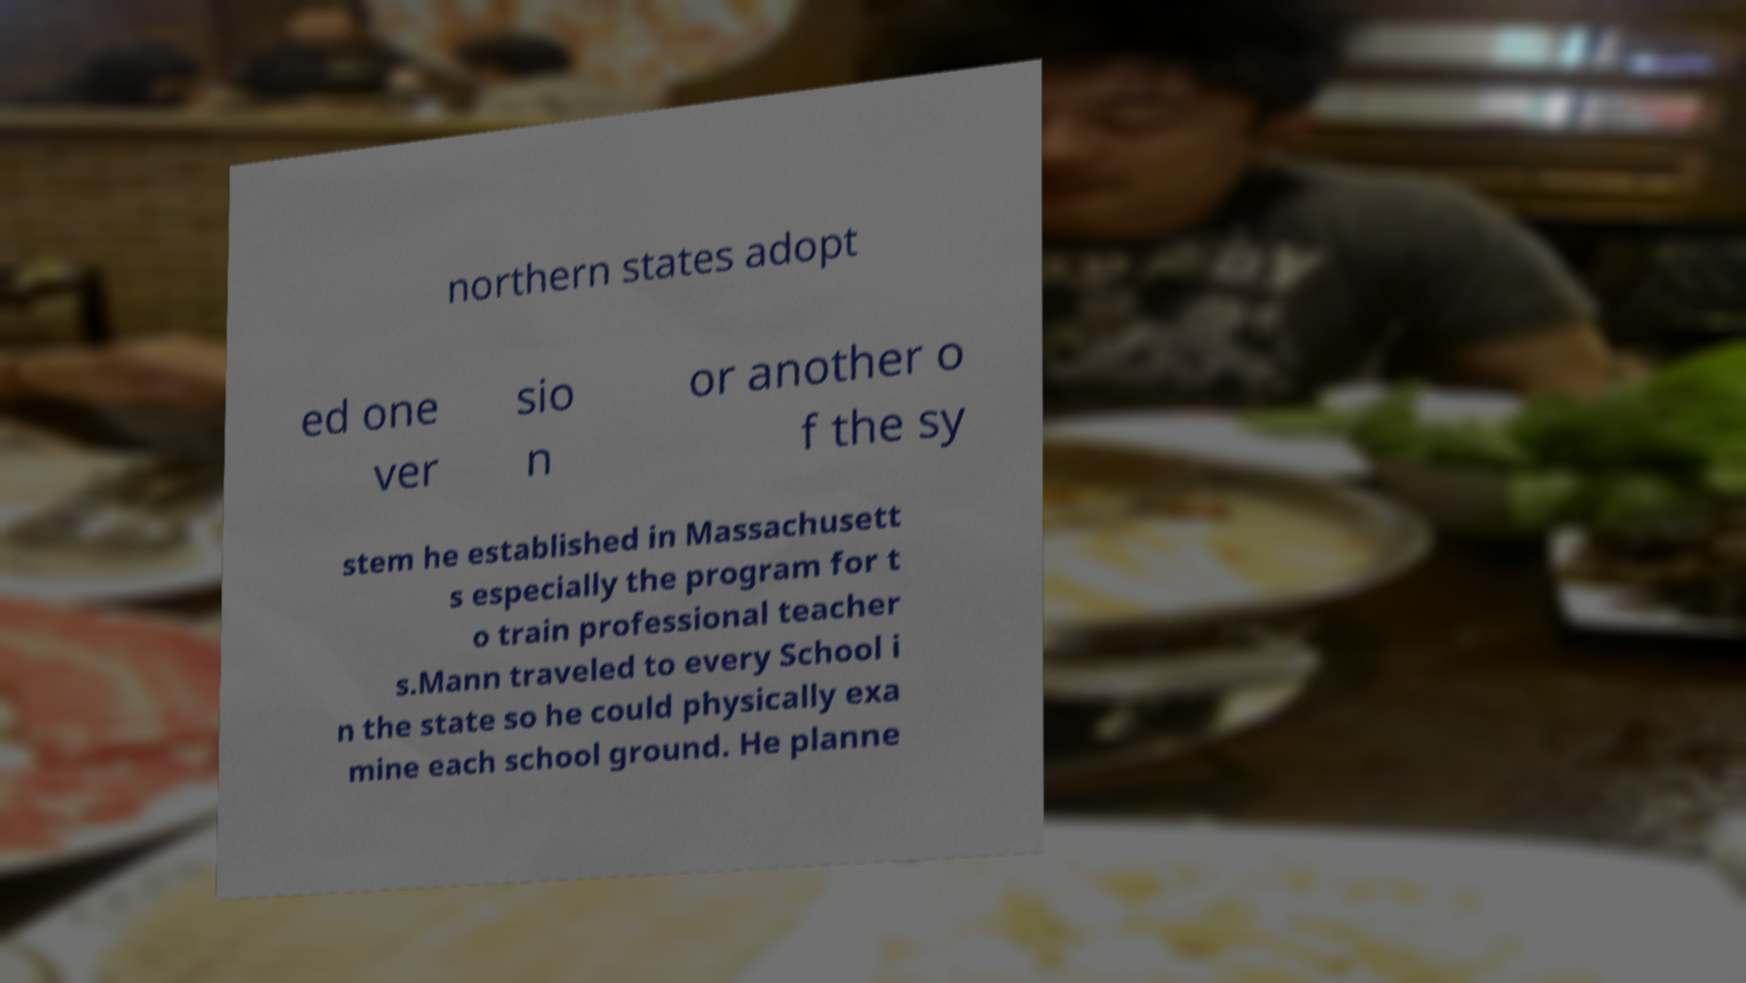Please identify and transcribe the text found in this image. northern states adopt ed one ver sio n or another o f the sy stem he established in Massachusett s especially the program for t o train professional teacher s.Mann traveled to every School i n the state so he could physically exa mine each school ground. He planne 